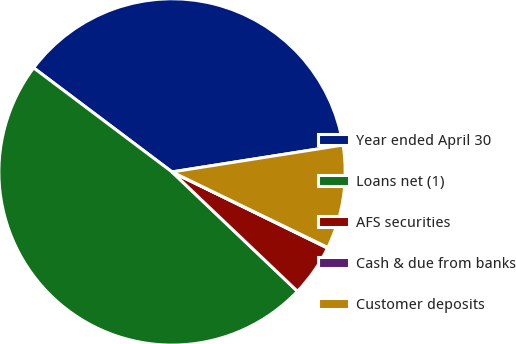Convert chart to OTSL. <chart><loc_0><loc_0><loc_500><loc_500><pie_chart><fcel>Year ended April 30<fcel>Loans net (1)<fcel>AFS securities<fcel>Cash & due from banks<fcel>Customer deposits<nl><fcel>37.25%<fcel>48.15%<fcel>4.86%<fcel>0.06%<fcel>9.67%<nl></chart> 